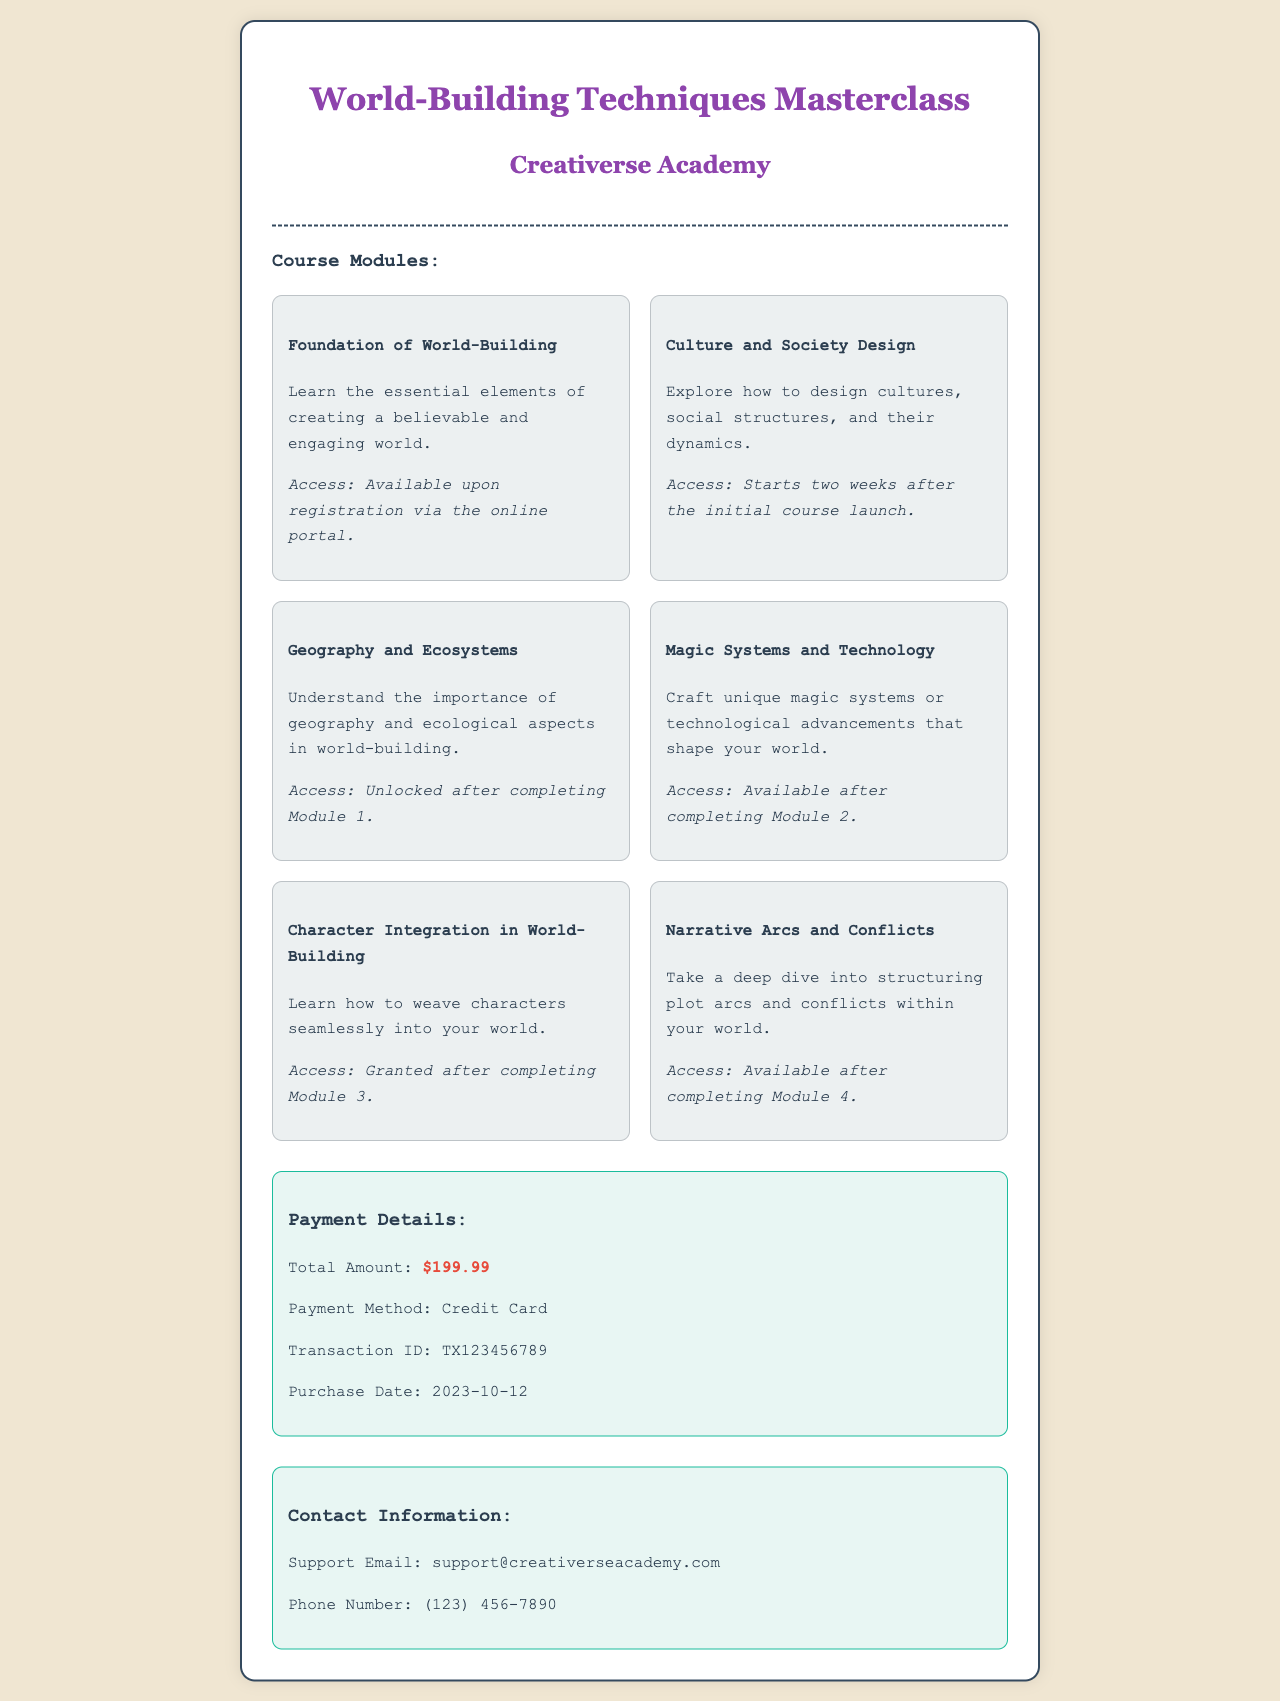What is the course title? The course title is stated at the top of the document, which is "World-Building Techniques Masterclass."
Answer: World-Building Techniques Masterclass Who is the provider of the course? The provider is mentioned below the course title, specifically "Creativerse Academy."
Answer: Creativerse Academy What is the total amount paid for the course? The total amount is listed in the payment details section of the receipt as $199.99.
Answer: $199.99 When was the purchase made? The purchase date is specified in the payment details and is listed as 2023-10-12.
Answer: 2023-10-12 What is the payment method used? The payment method is mentioned in the payment details section, which states "Credit Card."
Answer: Credit Card How many course modules are listed? The number of course modules is determined by counting the modules displayed under the "Course Modules" section, which totals six.
Answer: 6 Which module requires completion of Module 3 for access? The document specifies that "Character Integration in World-Building" is available after completing Module 3.
Answer: Character Integration in World-Building What is the contact email for support? The support email is stated in the contact information section, which is "support@creativerseacademy.com."
Answer: support@creativerseacademy.com What module starts two weeks after the initial course launch? The module that starts two weeks after the initial course launch is "Culture and Society Design."
Answer: Culture and Society Design 